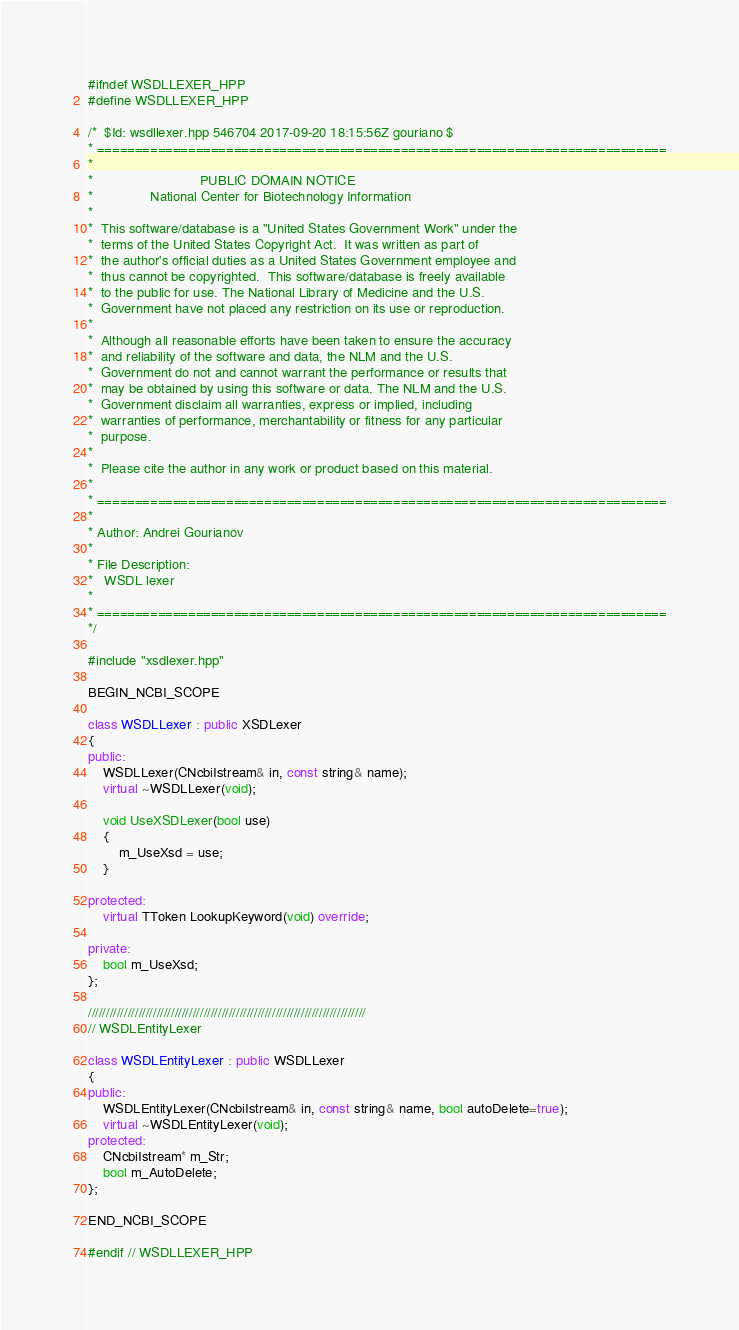<code> <loc_0><loc_0><loc_500><loc_500><_C++_>#ifndef WSDLLEXER_HPP
#define WSDLLEXER_HPP

/*  $Id: wsdllexer.hpp 546704 2017-09-20 18:15:56Z gouriano $
* ===========================================================================
*
*                            PUBLIC DOMAIN NOTICE
*               National Center for Biotechnology Information
*
*  This software/database is a "United States Government Work" under the
*  terms of the United States Copyright Act.  It was written as part of
*  the author's official duties as a United States Government employee and
*  thus cannot be copyrighted.  This software/database is freely available
*  to the public for use. The National Library of Medicine and the U.S.
*  Government have not placed any restriction on its use or reproduction.
*
*  Although all reasonable efforts have been taken to ensure the accuracy
*  and reliability of the software and data, the NLM and the U.S.
*  Government do not and cannot warrant the performance or results that
*  may be obtained by using this software or data. The NLM and the U.S.
*  Government disclaim all warranties, express or implied, including
*  warranties of performance, merchantability or fitness for any particular
*  purpose.
*
*  Please cite the author in any work or product based on this material.
*
* ===========================================================================
*
* Author: Andrei Gourianov
*
* File Description:
*   WSDL lexer
*
* ===========================================================================
*/

#include "xsdlexer.hpp"

BEGIN_NCBI_SCOPE

class WSDLLexer : public XSDLexer
{
public:
    WSDLLexer(CNcbiIstream& in, const string& name);
    virtual ~WSDLLexer(void);

    void UseXSDLexer(bool use)
    {
        m_UseXsd = use;
    }

protected:
    virtual TToken LookupKeyword(void) override;

private:
    bool m_UseXsd;
};

/////////////////////////////////////////////////////////////////////////////
// WSDLEntityLexer

class WSDLEntityLexer : public WSDLLexer
{
public:
    WSDLEntityLexer(CNcbiIstream& in, const string& name, bool autoDelete=true);
    virtual ~WSDLEntityLexer(void);
protected:
    CNcbiIstream* m_Str;
    bool m_AutoDelete;
};

END_NCBI_SCOPE

#endif // WSDLLEXER_HPP
</code> 